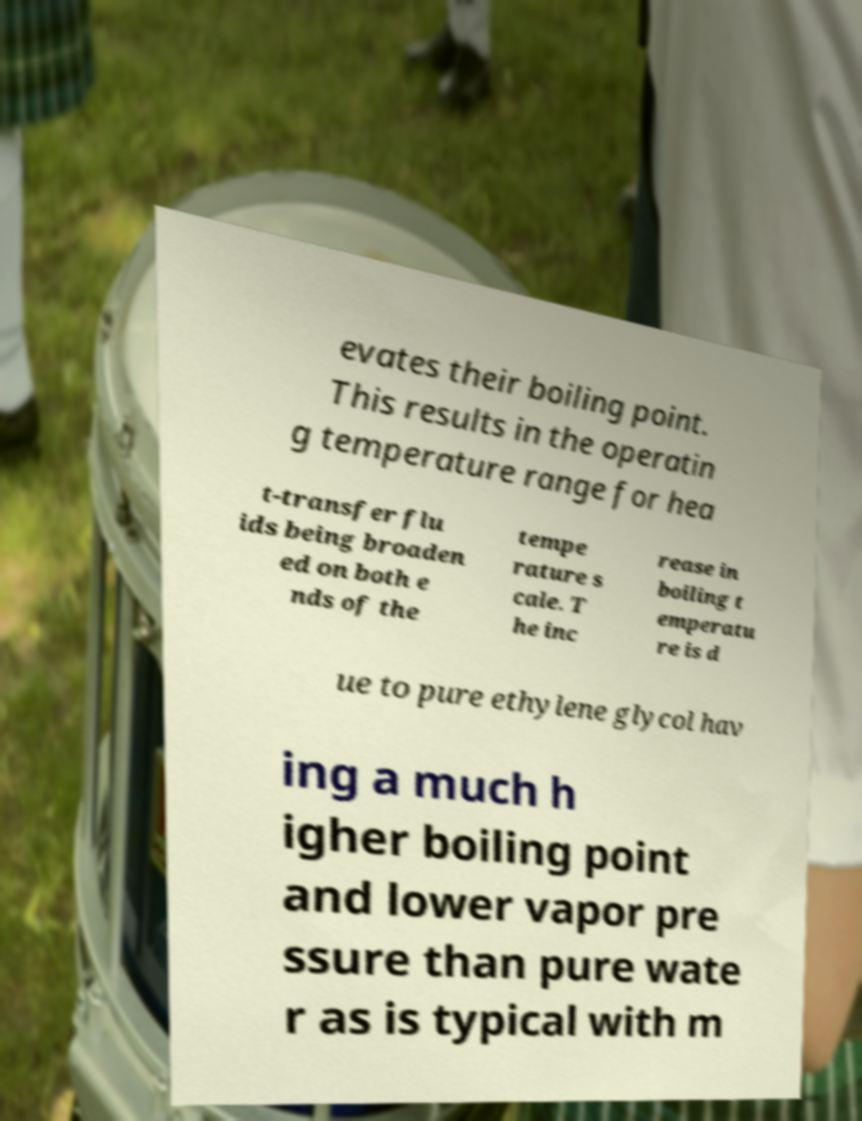Can you accurately transcribe the text from the provided image for me? evates their boiling point. This results in the operatin g temperature range for hea t-transfer flu ids being broaden ed on both e nds of the tempe rature s cale. T he inc rease in boiling t emperatu re is d ue to pure ethylene glycol hav ing a much h igher boiling point and lower vapor pre ssure than pure wate r as is typical with m 